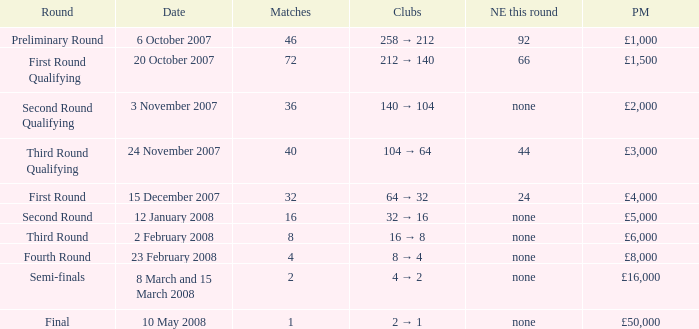How many new entries this round have clubs 2 → 1? None. 